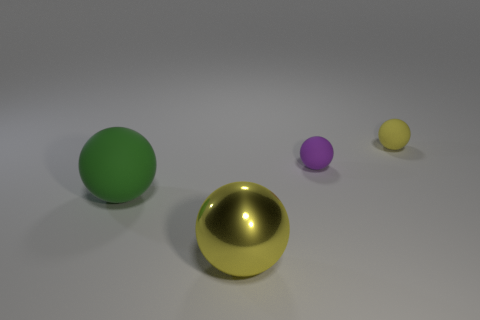How many yellow balls must be subtracted to get 1 yellow balls? 1 Add 4 yellow shiny spheres. How many objects exist? 8 Add 4 large yellow shiny balls. How many large yellow shiny balls are left? 5 Add 2 big brown metal balls. How many big brown metal balls exist? 2 Subtract 0 red blocks. How many objects are left? 4 Subtract all large yellow rubber blocks. Subtract all big green things. How many objects are left? 3 